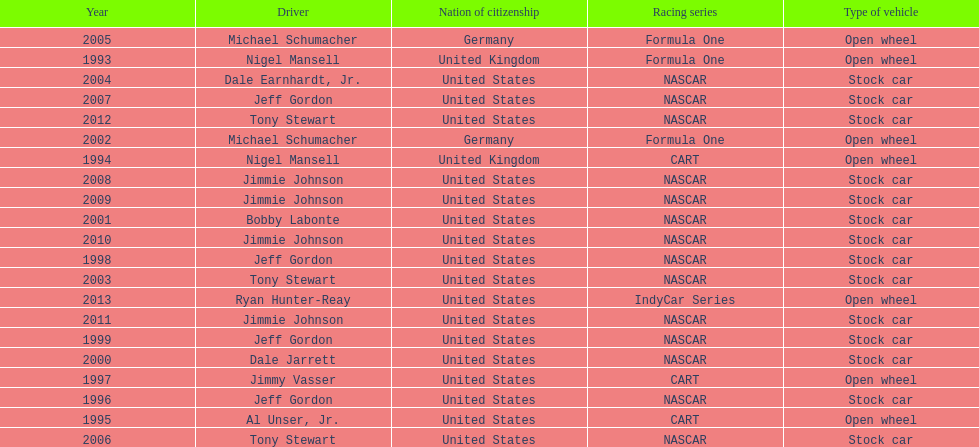How many total row entries are there? 21. 